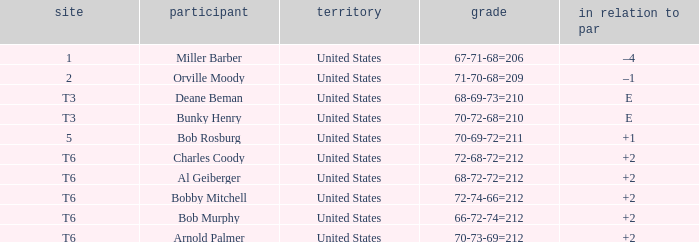What is the score of player bob rosburg? 70-69-72=211. 